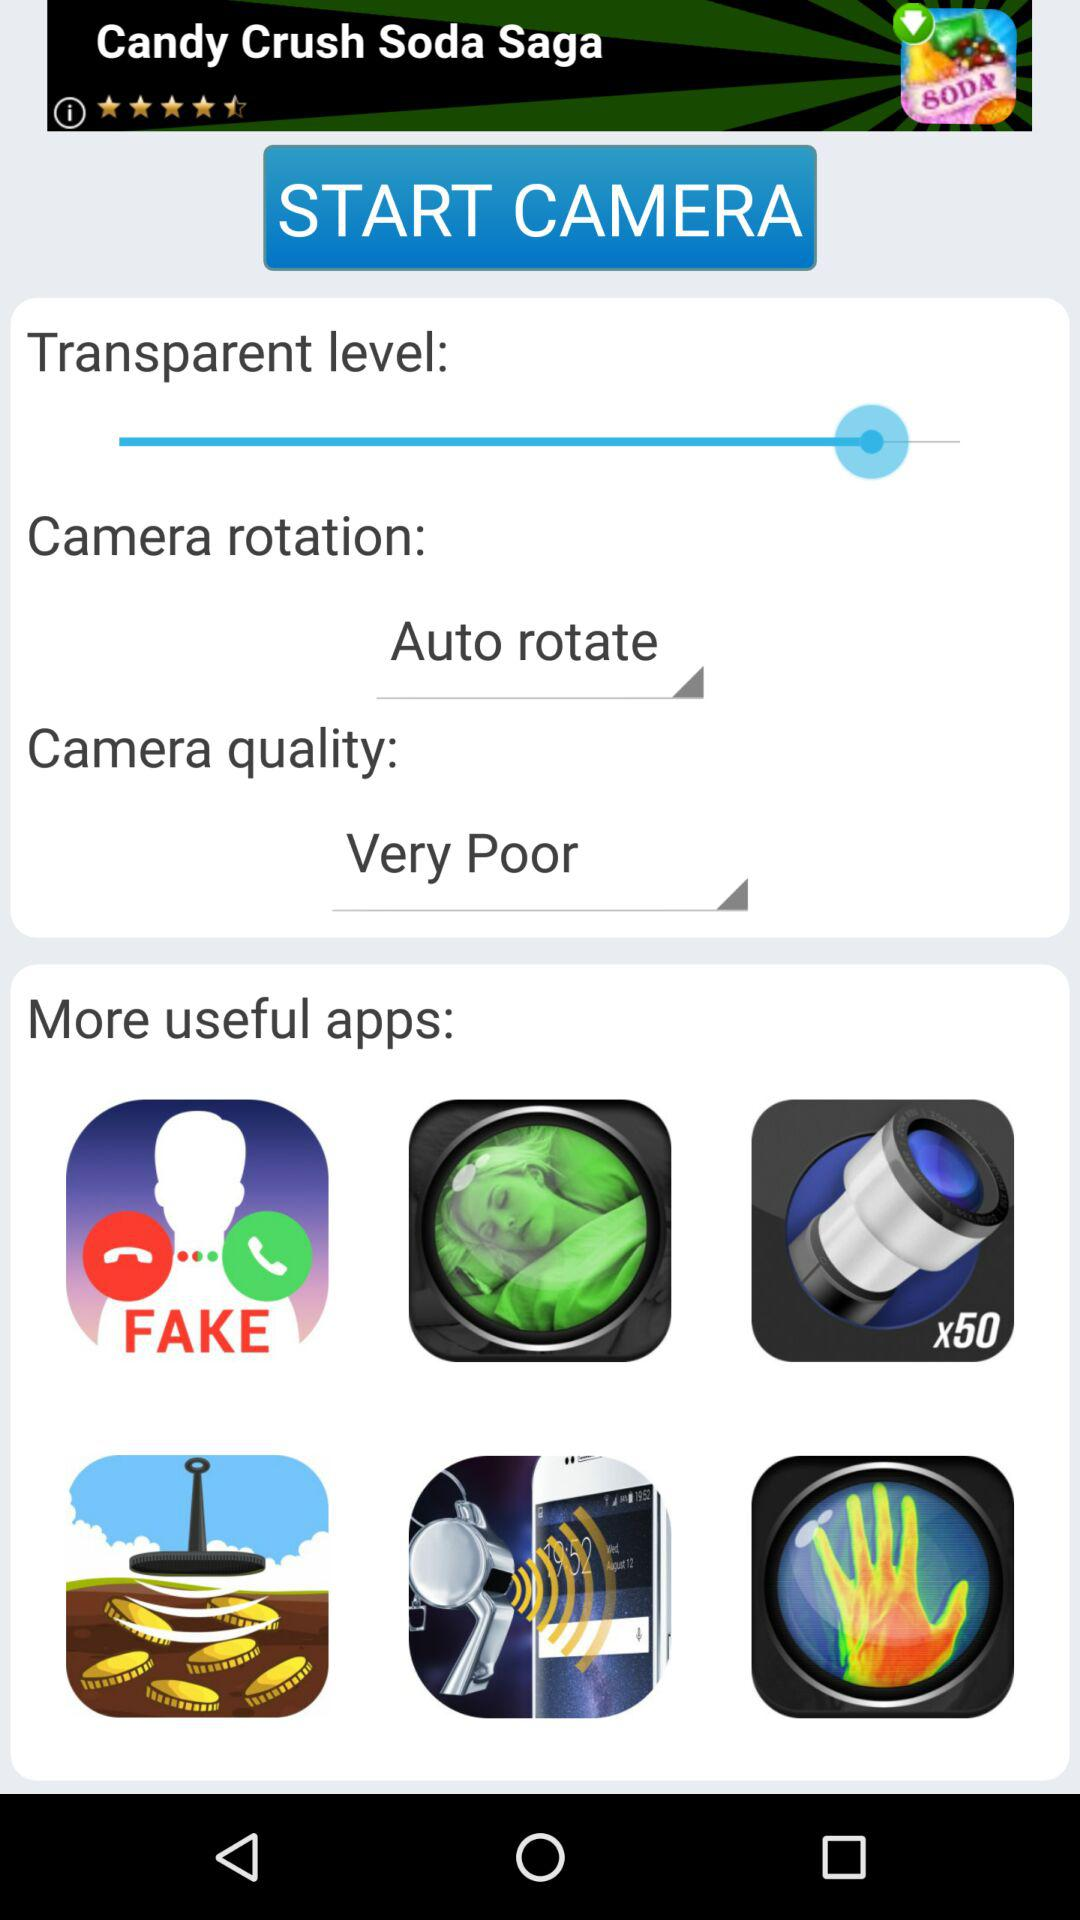What is the selected camera rotation? The selected camera rotation is "Auto rotate". 